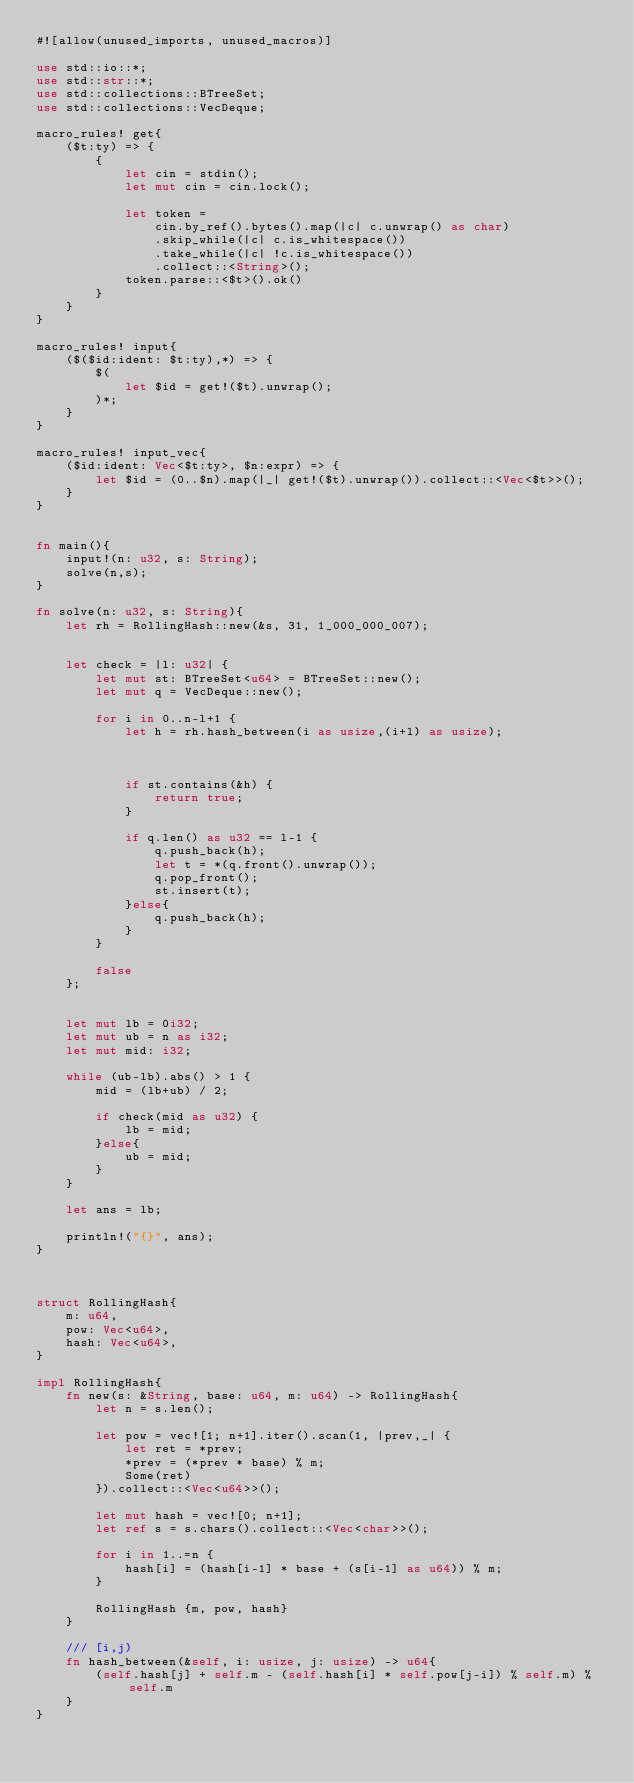Convert code to text. <code><loc_0><loc_0><loc_500><loc_500><_Rust_>#![allow(unused_imports, unused_macros)]

use std::io::*;
use std::str::*;
use std::collections::BTreeSet;
use std::collections::VecDeque;

macro_rules! get{
    ($t:ty) => {
        {
            let cin = stdin();
            let mut cin = cin.lock();
            
            let token =
                cin.by_ref().bytes().map(|c| c.unwrap() as char)
                .skip_while(|c| c.is_whitespace())
                .take_while(|c| !c.is_whitespace())
                .collect::<String>();
            token.parse::<$t>().ok()
        }
    }
}

macro_rules! input{
    ($($id:ident: $t:ty),*) => {
        $(
            let $id = get!($t).unwrap();
        )*;
    }
}

macro_rules! input_vec{
    ($id:ident: Vec<$t:ty>, $n:expr) => {
        let $id = (0..$n).map(|_| get!($t).unwrap()).collect::<Vec<$t>>();
    }
}


fn main(){
    input!(n: u32, s: String);
    solve(n,s);
}

fn solve(n: u32, s: String){
    let rh = RollingHash::new(&s, 31, 1_000_000_007);


    let check = |l: u32| {
        let mut st: BTreeSet<u64> = BTreeSet::new();
        let mut q = VecDeque::new();

        for i in 0..n-l+1 {
            let h = rh.hash_between(i as usize,(i+l) as usize);

            

            if st.contains(&h) {
                return true;
            }

            if q.len() as u32 == l-1 {
                q.push_back(h);
                let t = *(q.front().unwrap());
                q.pop_front();
                st.insert(t);
            }else{
                q.push_back(h);
            }
        }
        
        false
    };


    let mut lb = 0i32;
    let mut ub = n as i32;
    let mut mid: i32;

    while (ub-lb).abs() > 1 {
        mid = (lb+ub) / 2;

        if check(mid as u32) {
            lb = mid;
        }else{
            ub = mid;
        }
    }
        
    let ans = lb;

    println!("{}", ans);
}



struct RollingHash{
    m: u64,
    pow: Vec<u64>,
    hash: Vec<u64>,
}

impl RollingHash{
    fn new(s: &String, base: u64, m: u64) -> RollingHash{
        let n = s.len();
        
        let pow = vec![1; n+1].iter().scan(1, |prev,_| {
            let ret = *prev;
            *prev = (*prev * base) % m;
            Some(ret)
        }).collect::<Vec<u64>>();

        let mut hash = vec![0; n+1];
        let ref s = s.chars().collect::<Vec<char>>();

        for i in 1..=n {
            hash[i] = (hash[i-1] * base + (s[i-1] as u64)) % m;
        }

        RollingHash {m, pow, hash}
    }

    /// [i,j)
    fn hash_between(&self, i: usize, j: usize) -> u64{
        (self.hash[j] + self.m - (self.hash[i] * self.pow[j-i]) % self.m) % self.m
    }
}
</code> 